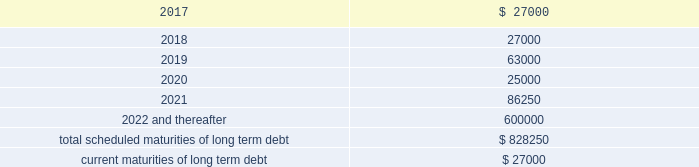Be adjusted by reference to a grid ( the 201cpricing grid 201d ) based on the consolidated leverage ratio and ranges between 1.00% ( 1.00 % ) to 1.25% ( 1.25 % ) for adjusted libor loans and 0.00% ( 0.00 % ) to 0.25% ( 0.25 % ) for alternate base rate loans .
The weighted average interest rate under the outstanding term loans and revolving credit facility borrowings was 1.6% ( 1.6 % ) and 1.3% ( 1.3 % ) during the years ended december 31 , 2016 and 2015 , respectively .
The company pays a commitment fee on the average daily unused amount of the revolving credit facility and certain fees with respect to letters of credit .
As of december 31 , 2016 , the commitment fee was 15.0 basis points .
Since inception , the company incurred and deferred $ 3.9 million in financing costs in connection with the credit agreement .
3.250% ( 3.250 % ) senior notes in june 2016 , the company issued $ 600.0 million aggregate principal amount of 3.250% ( 3.250 % ) senior unsecured notes due june 15 , 2026 ( the 201cnotes 201d ) .
The proceeds were used to pay down amounts outstanding under the revolving credit facility .
Interest is payable semi-annually on june 15 and december 15 beginning december 15 , 2016 .
Prior to march 15 , 2026 ( three months prior to the maturity date of the notes ) , the company may redeem some or all of the notes at any time or from time to time at a redemption price equal to the greater of 100% ( 100 % ) of the principal amount of the notes to be redeemed or a 201cmake-whole 201d amount applicable to such notes as described in the indenture governing the notes , plus accrued and unpaid interest to , but excluding , the redemption date .
On or after march 15 , 2026 ( three months prior to the maturity date of the notes ) , the company may redeem some or all of the notes at any time or from time to time at a redemption price equal to 100% ( 100 % ) of the principal amount of the notes to be redeemed , plus accrued and unpaid interest to , but excluding , the redemption date .
The indenture governing the notes contains covenants , including limitations that restrict the company 2019s ability and the ability of certain of its subsidiaries to create or incur secured indebtedness and enter into sale and leaseback transactions and the company 2019s ability to consolidate , merge or transfer all or substantially all of its properties or assets to another person , in each case subject to material exceptions described in the indenture .
The company incurred and deferred $ 5.3 million in financing costs in connection with the notes .
Other long term debt in december 2012 , the company entered into a $ 50.0 million recourse loan collateralized by the land , buildings and tenant improvements comprising the company 2019s corporate headquarters .
The loan has a seven year term and maturity date of december 2019 .
The loan bears interest at one month libor plus a margin of 1.50% ( 1.50 % ) , and allows for prepayment without penalty .
The loan includes covenants and events of default substantially consistent with the company 2019s credit agreement discussed above .
The loan also requires prior approval of the lender for certain matters related to the property , including transfers of any interest in the property .
As of december 31 , 2016 and 2015 , the outstanding balance on the loan was $ 42.0 million and $ 44.0 million , respectively .
The weighted average interest rate on the loan was 2.0% ( 2.0 % ) and 1.7% ( 1.7 % ) for the years ended december 31 , 2016 and 2015 , respectively .
The following are the scheduled maturities of long term debt as of december 31 , 2016 : ( in thousands ) .

What percentage of total scheduled maturities of long term debt are due in 2020? 
Computations: (25000 / 828250)
Answer: 0.03018. 